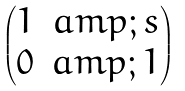<formula> <loc_0><loc_0><loc_500><loc_500>\begin{pmatrix} 1 & a m p ; s \\ 0 & a m p ; 1 \end{pmatrix}</formula> 